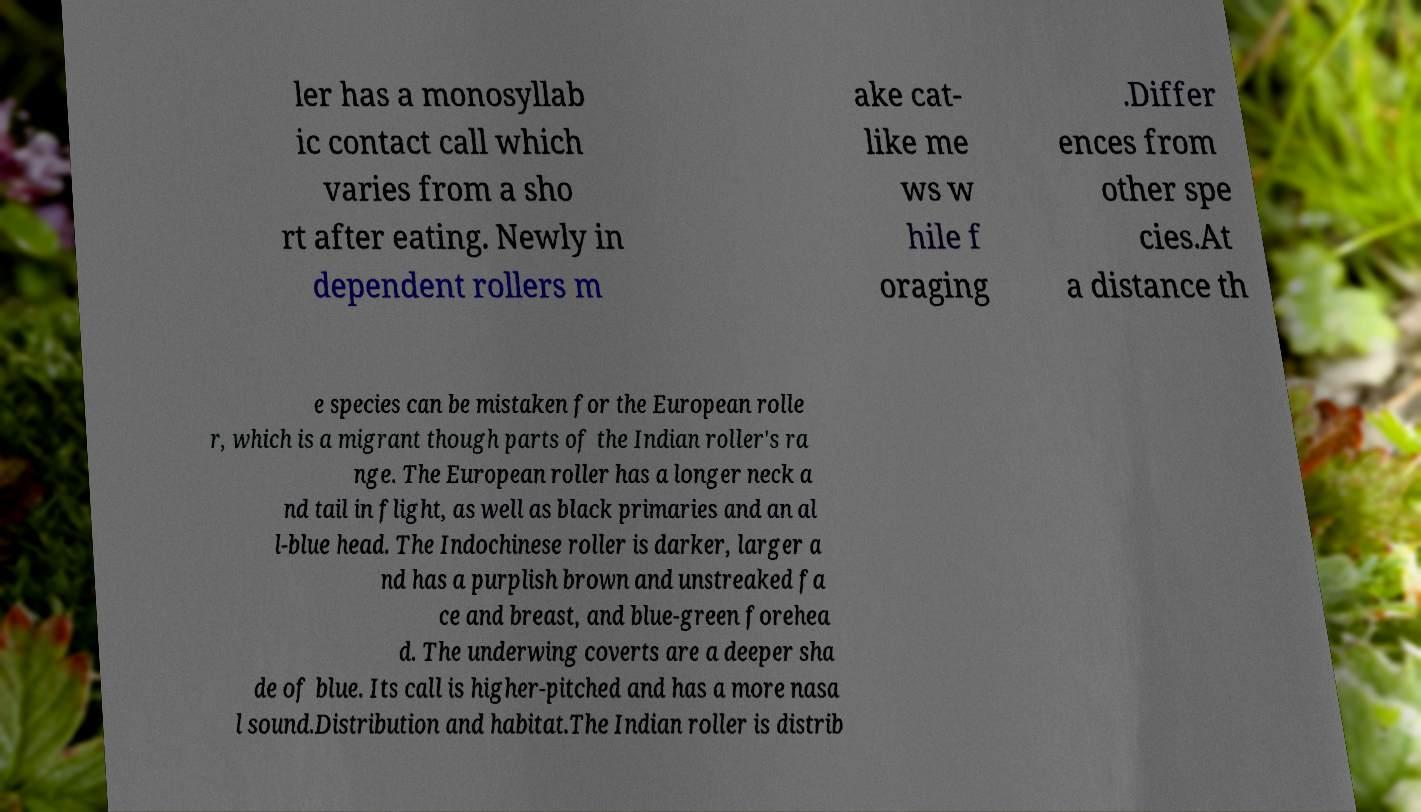Please read and relay the text visible in this image. What does it say? ler has a monosyllab ic contact call which varies from a sho rt after eating. Newly in dependent rollers m ake cat- like me ws w hile f oraging .Differ ences from other spe cies.At a distance th e species can be mistaken for the European rolle r, which is a migrant though parts of the Indian roller's ra nge. The European roller has a longer neck a nd tail in flight, as well as black primaries and an al l-blue head. The Indochinese roller is darker, larger a nd has a purplish brown and unstreaked fa ce and breast, and blue-green forehea d. The underwing coverts are a deeper sha de of blue. Its call is higher-pitched and has a more nasa l sound.Distribution and habitat.The Indian roller is distrib 